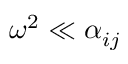<formula> <loc_0><loc_0><loc_500><loc_500>\omega ^ { 2 } \ll \alpha _ { i j }</formula> 